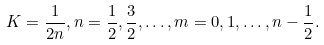Convert formula to latex. <formula><loc_0><loc_0><loc_500><loc_500>K = \frac { 1 } { 2 n } , n = \frac { 1 } { 2 } , \frac { 3 } { 2 } , \dots , m = 0 , 1 , \dots , n - \frac { 1 } { 2 } .</formula> 